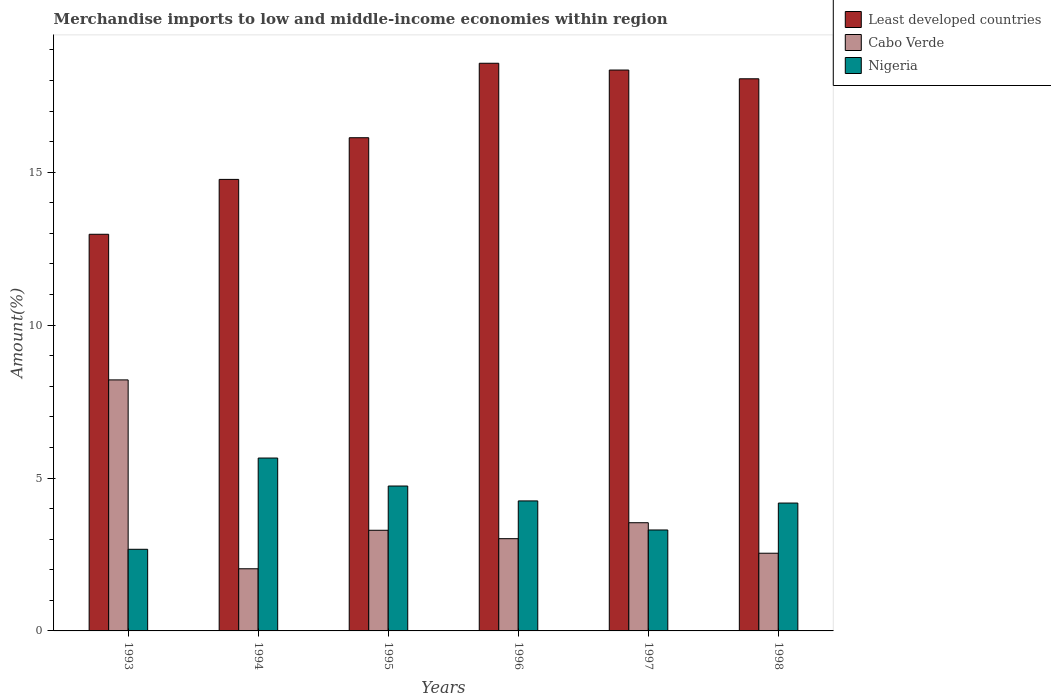How many different coloured bars are there?
Offer a terse response. 3. How many groups of bars are there?
Offer a very short reply. 6. Are the number of bars per tick equal to the number of legend labels?
Keep it short and to the point. Yes. How many bars are there on the 1st tick from the left?
Make the answer very short. 3. How many bars are there on the 6th tick from the right?
Your answer should be compact. 3. What is the label of the 3rd group of bars from the left?
Ensure brevity in your answer.  1995. What is the percentage of amount earned from merchandise imports in Least developed countries in 1997?
Your response must be concise. 18.34. Across all years, what is the maximum percentage of amount earned from merchandise imports in Cabo Verde?
Your response must be concise. 8.21. Across all years, what is the minimum percentage of amount earned from merchandise imports in Least developed countries?
Your response must be concise. 12.97. In which year was the percentage of amount earned from merchandise imports in Nigeria minimum?
Your answer should be very brief. 1993. What is the total percentage of amount earned from merchandise imports in Cabo Verde in the graph?
Give a very brief answer. 22.63. What is the difference between the percentage of amount earned from merchandise imports in Cabo Verde in 1994 and that in 1996?
Provide a short and direct response. -0.98. What is the difference between the percentage of amount earned from merchandise imports in Least developed countries in 1993 and the percentage of amount earned from merchandise imports in Nigeria in 1994?
Provide a short and direct response. 7.32. What is the average percentage of amount earned from merchandise imports in Nigeria per year?
Provide a short and direct response. 4.13. In the year 1998, what is the difference between the percentage of amount earned from merchandise imports in Cabo Verde and percentage of amount earned from merchandise imports in Nigeria?
Provide a short and direct response. -1.64. What is the ratio of the percentage of amount earned from merchandise imports in Cabo Verde in 1996 to that in 1998?
Ensure brevity in your answer.  1.19. Is the percentage of amount earned from merchandise imports in Cabo Verde in 1993 less than that in 1996?
Offer a terse response. No. What is the difference between the highest and the second highest percentage of amount earned from merchandise imports in Least developed countries?
Offer a terse response. 0.22. What is the difference between the highest and the lowest percentage of amount earned from merchandise imports in Nigeria?
Give a very brief answer. 2.98. In how many years, is the percentage of amount earned from merchandise imports in Least developed countries greater than the average percentage of amount earned from merchandise imports in Least developed countries taken over all years?
Give a very brief answer. 3. Is the sum of the percentage of amount earned from merchandise imports in Least developed countries in 1995 and 1997 greater than the maximum percentage of amount earned from merchandise imports in Nigeria across all years?
Provide a short and direct response. Yes. What does the 2nd bar from the left in 1998 represents?
Provide a short and direct response. Cabo Verde. What does the 3rd bar from the right in 1996 represents?
Ensure brevity in your answer.  Least developed countries. Is it the case that in every year, the sum of the percentage of amount earned from merchandise imports in Nigeria and percentage of amount earned from merchandise imports in Least developed countries is greater than the percentage of amount earned from merchandise imports in Cabo Verde?
Offer a very short reply. Yes. How many bars are there?
Your answer should be very brief. 18. What is the difference between two consecutive major ticks on the Y-axis?
Keep it short and to the point. 5. Does the graph contain any zero values?
Your answer should be very brief. No. How are the legend labels stacked?
Offer a very short reply. Vertical. What is the title of the graph?
Offer a very short reply. Merchandise imports to low and middle-income economies within region. What is the label or title of the Y-axis?
Make the answer very short. Amount(%). What is the Amount(%) in Least developed countries in 1993?
Your response must be concise. 12.97. What is the Amount(%) in Cabo Verde in 1993?
Provide a succinct answer. 8.21. What is the Amount(%) in Nigeria in 1993?
Make the answer very short. 2.67. What is the Amount(%) of Least developed countries in 1994?
Provide a succinct answer. 14.76. What is the Amount(%) of Cabo Verde in 1994?
Offer a very short reply. 2.03. What is the Amount(%) in Nigeria in 1994?
Keep it short and to the point. 5.65. What is the Amount(%) of Least developed countries in 1995?
Your response must be concise. 16.13. What is the Amount(%) of Cabo Verde in 1995?
Your answer should be very brief. 3.29. What is the Amount(%) in Nigeria in 1995?
Give a very brief answer. 4.74. What is the Amount(%) of Least developed countries in 1996?
Ensure brevity in your answer.  18.56. What is the Amount(%) of Cabo Verde in 1996?
Ensure brevity in your answer.  3.02. What is the Amount(%) of Nigeria in 1996?
Offer a terse response. 4.25. What is the Amount(%) of Least developed countries in 1997?
Keep it short and to the point. 18.34. What is the Amount(%) of Cabo Verde in 1997?
Your answer should be very brief. 3.54. What is the Amount(%) in Nigeria in 1997?
Offer a terse response. 3.3. What is the Amount(%) in Least developed countries in 1998?
Keep it short and to the point. 18.05. What is the Amount(%) of Cabo Verde in 1998?
Offer a terse response. 2.54. What is the Amount(%) in Nigeria in 1998?
Offer a very short reply. 4.18. Across all years, what is the maximum Amount(%) in Least developed countries?
Provide a short and direct response. 18.56. Across all years, what is the maximum Amount(%) of Cabo Verde?
Offer a very short reply. 8.21. Across all years, what is the maximum Amount(%) in Nigeria?
Keep it short and to the point. 5.65. Across all years, what is the minimum Amount(%) in Least developed countries?
Keep it short and to the point. 12.97. Across all years, what is the minimum Amount(%) in Cabo Verde?
Offer a very short reply. 2.03. Across all years, what is the minimum Amount(%) of Nigeria?
Your response must be concise. 2.67. What is the total Amount(%) in Least developed countries in the graph?
Your answer should be very brief. 98.82. What is the total Amount(%) in Cabo Verde in the graph?
Ensure brevity in your answer.  22.63. What is the total Amount(%) in Nigeria in the graph?
Ensure brevity in your answer.  24.79. What is the difference between the Amount(%) in Least developed countries in 1993 and that in 1994?
Provide a succinct answer. -1.79. What is the difference between the Amount(%) of Cabo Verde in 1993 and that in 1994?
Your response must be concise. 6.18. What is the difference between the Amount(%) in Nigeria in 1993 and that in 1994?
Your response must be concise. -2.98. What is the difference between the Amount(%) in Least developed countries in 1993 and that in 1995?
Provide a succinct answer. -3.16. What is the difference between the Amount(%) of Cabo Verde in 1993 and that in 1995?
Provide a short and direct response. 4.92. What is the difference between the Amount(%) in Nigeria in 1993 and that in 1995?
Ensure brevity in your answer.  -2.07. What is the difference between the Amount(%) in Least developed countries in 1993 and that in 1996?
Provide a succinct answer. -5.59. What is the difference between the Amount(%) in Cabo Verde in 1993 and that in 1996?
Your answer should be compact. 5.19. What is the difference between the Amount(%) of Nigeria in 1993 and that in 1996?
Keep it short and to the point. -1.58. What is the difference between the Amount(%) in Least developed countries in 1993 and that in 1997?
Your answer should be compact. -5.37. What is the difference between the Amount(%) of Cabo Verde in 1993 and that in 1997?
Your response must be concise. 4.67. What is the difference between the Amount(%) of Nigeria in 1993 and that in 1997?
Your answer should be compact. -0.63. What is the difference between the Amount(%) of Least developed countries in 1993 and that in 1998?
Make the answer very short. -5.08. What is the difference between the Amount(%) in Cabo Verde in 1993 and that in 1998?
Offer a very short reply. 5.67. What is the difference between the Amount(%) in Nigeria in 1993 and that in 1998?
Offer a terse response. -1.51. What is the difference between the Amount(%) in Least developed countries in 1994 and that in 1995?
Provide a short and direct response. -1.36. What is the difference between the Amount(%) of Cabo Verde in 1994 and that in 1995?
Offer a terse response. -1.26. What is the difference between the Amount(%) of Nigeria in 1994 and that in 1995?
Provide a succinct answer. 0.92. What is the difference between the Amount(%) of Least developed countries in 1994 and that in 1996?
Ensure brevity in your answer.  -3.8. What is the difference between the Amount(%) of Cabo Verde in 1994 and that in 1996?
Your response must be concise. -0.98. What is the difference between the Amount(%) in Nigeria in 1994 and that in 1996?
Your response must be concise. 1.4. What is the difference between the Amount(%) in Least developed countries in 1994 and that in 1997?
Your answer should be very brief. -3.58. What is the difference between the Amount(%) in Cabo Verde in 1994 and that in 1997?
Your answer should be very brief. -1.51. What is the difference between the Amount(%) in Nigeria in 1994 and that in 1997?
Provide a short and direct response. 2.35. What is the difference between the Amount(%) of Least developed countries in 1994 and that in 1998?
Ensure brevity in your answer.  -3.29. What is the difference between the Amount(%) in Cabo Verde in 1994 and that in 1998?
Give a very brief answer. -0.51. What is the difference between the Amount(%) in Nigeria in 1994 and that in 1998?
Give a very brief answer. 1.47. What is the difference between the Amount(%) of Least developed countries in 1995 and that in 1996?
Your answer should be compact. -2.44. What is the difference between the Amount(%) in Cabo Verde in 1995 and that in 1996?
Keep it short and to the point. 0.27. What is the difference between the Amount(%) of Nigeria in 1995 and that in 1996?
Keep it short and to the point. 0.49. What is the difference between the Amount(%) of Least developed countries in 1995 and that in 1997?
Keep it short and to the point. -2.21. What is the difference between the Amount(%) of Cabo Verde in 1995 and that in 1997?
Your answer should be compact. -0.25. What is the difference between the Amount(%) in Nigeria in 1995 and that in 1997?
Your answer should be compact. 1.44. What is the difference between the Amount(%) of Least developed countries in 1995 and that in 1998?
Your answer should be very brief. -1.93. What is the difference between the Amount(%) of Cabo Verde in 1995 and that in 1998?
Keep it short and to the point. 0.75. What is the difference between the Amount(%) in Nigeria in 1995 and that in 1998?
Your answer should be compact. 0.56. What is the difference between the Amount(%) in Least developed countries in 1996 and that in 1997?
Provide a succinct answer. 0.22. What is the difference between the Amount(%) in Cabo Verde in 1996 and that in 1997?
Your answer should be compact. -0.52. What is the difference between the Amount(%) in Nigeria in 1996 and that in 1997?
Provide a short and direct response. 0.95. What is the difference between the Amount(%) in Least developed countries in 1996 and that in 1998?
Make the answer very short. 0.51. What is the difference between the Amount(%) of Cabo Verde in 1996 and that in 1998?
Provide a short and direct response. 0.48. What is the difference between the Amount(%) of Nigeria in 1996 and that in 1998?
Your response must be concise. 0.07. What is the difference between the Amount(%) in Least developed countries in 1997 and that in 1998?
Make the answer very short. 0.29. What is the difference between the Amount(%) in Cabo Verde in 1997 and that in 1998?
Your answer should be very brief. 1. What is the difference between the Amount(%) of Nigeria in 1997 and that in 1998?
Your response must be concise. -0.88. What is the difference between the Amount(%) of Least developed countries in 1993 and the Amount(%) of Cabo Verde in 1994?
Provide a short and direct response. 10.94. What is the difference between the Amount(%) in Least developed countries in 1993 and the Amount(%) in Nigeria in 1994?
Make the answer very short. 7.32. What is the difference between the Amount(%) in Cabo Verde in 1993 and the Amount(%) in Nigeria in 1994?
Give a very brief answer. 2.55. What is the difference between the Amount(%) in Least developed countries in 1993 and the Amount(%) in Cabo Verde in 1995?
Give a very brief answer. 9.68. What is the difference between the Amount(%) in Least developed countries in 1993 and the Amount(%) in Nigeria in 1995?
Provide a short and direct response. 8.23. What is the difference between the Amount(%) in Cabo Verde in 1993 and the Amount(%) in Nigeria in 1995?
Make the answer very short. 3.47. What is the difference between the Amount(%) of Least developed countries in 1993 and the Amount(%) of Cabo Verde in 1996?
Your answer should be very brief. 9.95. What is the difference between the Amount(%) of Least developed countries in 1993 and the Amount(%) of Nigeria in 1996?
Give a very brief answer. 8.72. What is the difference between the Amount(%) in Cabo Verde in 1993 and the Amount(%) in Nigeria in 1996?
Your answer should be very brief. 3.96. What is the difference between the Amount(%) in Least developed countries in 1993 and the Amount(%) in Cabo Verde in 1997?
Provide a succinct answer. 9.43. What is the difference between the Amount(%) of Least developed countries in 1993 and the Amount(%) of Nigeria in 1997?
Provide a succinct answer. 9.67. What is the difference between the Amount(%) of Cabo Verde in 1993 and the Amount(%) of Nigeria in 1997?
Ensure brevity in your answer.  4.91. What is the difference between the Amount(%) of Least developed countries in 1993 and the Amount(%) of Cabo Verde in 1998?
Offer a terse response. 10.43. What is the difference between the Amount(%) in Least developed countries in 1993 and the Amount(%) in Nigeria in 1998?
Your answer should be compact. 8.79. What is the difference between the Amount(%) in Cabo Verde in 1993 and the Amount(%) in Nigeria in 1998?
Provide a succinct answer. 4.03. What is the difference between the Amount(%) of Least developed countries in 1994 and the Amount(%) of Cabo Verde in 1995?
Offer a terse response. 11.47. What is the difference between the Amount(%) of Least developed countries in 1994 and the Amount(%) of Nigeria in 1995?
Give a very brief answer. 10.03. What is the difference between the Amount(%) of Cabo Verde in 1994 and the Amount(%) of Nigeria in 1995?
Offer a very short reply. -2.71. What is the difference between the Amount(%) of Least developed countries in 1994 and the Amount(%) of Cabo Verde in 1996?
Offer a terse response. 11.75. What is the difference between the Amount(%) of Least developed countries in 1994 and the Amount(%) of Nigeria in 1996?
Provide a short and direct response. 10.51. What is the difference between the Amount(%) of Cabo Verde in 1994 and the Amount(%) of Nigeria in 1996?
Offer a very short reply. -2.22. What is the difference between the Amount(%) of Least developed countries in 1994 and the Amount(%) of Cabo Verde in 1997?
Your answer should be compact. 11.23. What is the difference between the Amount(%) of Least developed countries in 1994 and the Amount(%) of Nigeria in 1997?
Your answer should be very brief. 11.46. What is the difference between the Amount(%) of Cabo Verde in 1994 and the Amount(%) of Nigeria in 1997?
Offer a terse response. -1.27. What is the difference between the Amount(%) of Least developed countries in 1994 and the Amount(%) of Cabo Verde in 1998?
Offer a terse response. 12.22. What is the difference between the Amount(%) in Least developed countries in 1994 and the Amount(%) in Nigeria in 1998?
Make the answer very short. 10.58. What is the difference between the Amount(%) in Cabo Verde in 1994 and the Amount(%) in Nigeria in 1998?
Your response must be concise. -2.15. What is the difference between the Amount(%) in Least developed countries in 1995 and the Amount(%) in Cabo Verde in 1996?
Offer a terse response. 13.11. What is the difference between the Amount(%) in Least developed countries in 1995 and the Amount(%) in Nigeria in 1996?
Ensure brevity in your answer.  11.88. What is the difference between the Amount(%) in Cabo Verde in 1995 and the Amount(%) in Nigeria in 1996?
Your answer should be compact. -0.96. What is the difference between the Amount(%) of Least developed countries in 1995 and the Amount(%) of Cabo Verde in 1997?
Your answer should be very brief. 12.59. What is the difference between the Amount(%) of Least developed countries in 1995 and the Amount(%) of Nigeria in 1997?
Offer a terse response. 12.83. What is the difference between the Amount(%) in Cabo Verde in 1995 and the Amount(%) in Nigeria in 1997?
Offer a terse response. -0.01. What is the difference between the Amount(%) of Least developed countries in 1995 and the Amount(%) of Cabo Verde in 1998?
Offer a terse response. 13.59. What is the difference between the Amount(%) in Least developed countries in 1995 and the Amount(%) in Nigeria in 1998?
Give a very brief answer. 11.95. What is the difference between the Amount(%) in Cabo Verde in 1995 and the Amount(%) in Nigeria in 1998?
Give a very brief answer. -0.89. What is the difference between the Amount(%) of Least developed countries in 1996 and the Amount(%) of Cabo Verde in 1997?
Your response must be concise. 15.02. What is the difference between the Amount(%) in Least developed countries in 1996 and the Amount(%) in Nigeria in 1997?
Ensure brevity in your answer.  15.26. What is the difference between the Amount(%) in Cabo Verde in 1996 and the Amount(%) in Nigeria in 1997?
Provide a short and direct response. -0.28. What is the difference between the Amount(%) of Least developed countries in 1996 and the Amount(%) of Cabo Verde in 1998?
Keep it short and to the point. 16.02. What is the difference between the Amount(%) in Least developed countries in 1996 and the Amount(%) in Nigeria in 1998?
Make the answer very short. 14.38. What is the difference between the Amount(%) of Cabo Verde in 1996 and the Amount(%) of Nigeria in 1998?
Make the answer very short. -1.16. What is the difference between the Amount(%) in Least developed countries in 1997 and the Amount(%) in Cabo Verde in 1998?
Provide a succinct answer. 15.8. What is the difference between the Amount(%) of Least developed countries in 1997 and the Amount(%) of Nigeria in 1998?
Provide a short and direct response. 14.16. What is the difference between the Amount(%) of Cabo Verde in 1997 and the Amount(%) of Nigeria in 1998?
Offer a very short reply. -0.64. What is the average Amount(%) of Least developed countries per year?
Give a very brief answer. 16.47. What is the average Amount(%) in Cabo Verde per year?
Offer a terse response. 3.77. What is the average Amount(%) in Nigeria per year?
Make the answer very short. 4.13. In the year 1993, what is the difference between the Amount(%) in Least developed countries and Amount(%) in Cabo Verde?
Offer a very short reply. 4.76. In the year 1993, what is the difference between the Amount(%) of Least developed countries and Amount(%) of Nigeria?
Give a very brief answer. 10.3. In the year 1993, what is the difference between the Amount(%) of Cabo Verde and Amount(%) of Nigeria?
Your answer should be compact. 5.54. In the year 1994, what is the difference between the Amount(%) of Least developed countries and Amount(%) of Cabo Verde?
Give a very brief answer. 12.73. In the year 1994, what is the difference between the Amount(%) in Least developed countries and Amount(%) in Nigeria?
Your answer should be very brief. 9.11. In the year 1994, what is the difference between the Amount(%) in Cabo Verde and Amount(%) in Nigeria?
Your answer should be compact. -3.62. In the year 1995, what is the difference between the Amount(%) in Least developed countries and Amount(%) in Cabo Verde?
Make the answer very short. 12.84. In the year 1995, what is the difference between the Amount(%) in Least developed countries and Amount(%) in Nigeria?
Ensure brevity in your answer.  11.39. In the year 1995, what is the difference between the Amount(%) of Cabo Verde and Amount(%) of Nigeria?
Give a very brief answer. -1.45. In the year 1996, what is the difference between the Amount(%) in Least developed countries and Amount(%) in Cabo Verde?
Make the answer very short. 15.55. In the year 1996, what is the difference between the Amount(%) of Least developed countries and Amount(%) of Nigeria?
Your response must be concise. 14.31. In the year 1996, what is the difference between the Amount(%) in Cabo Verde and Amount(%) in Nigeria?
Provide a succinct answer. -1.23. In the year 1997, what is the difference between the Amount(%) in Least developed countries and Amount(%) in Cabo Verde?
Keep it short and to the point. 14.8. In the year 1997, what is the difference between the Amount(%) of Least developed countries and Amount(%) of Nigeria?
Your answer should be very brief. 15.04. In the year 1997, what is the difference between the Amount(%) of Cabo Verde and Amount(%) of Nigeria?
Make the answer very short. 0.24. In the year 1998, what is the difference between the Amount(%) of Least developed countries and Amount(%) of Cabo Verde?
Provide a succinct answer. 15.51. In the year 1998, what is the difference between the Amount(%) of Least developed countries and Amount(%) of Nigeria?
Give a very brief answer. 13.87. In the year 1998, what is the difference between the Amount(%) in Cabo Verde and Amount(%) in Nigeria?
Make the answer very short. -1.64. What is the ratio of the Amount(%) in Least developed countries in 1993 to that in 1994?
Provide a short and direct response. 0.88. What is the ratio of the Amount(%) in Cabo Verde in 1993 to that in 1994?
Give a very brief answer. 4.04. What is the ratio of the Amount(%) in Nigeria in 1993 to that in 1994?
Your response must be concise. 0.47. What is the ratio of the Amount(%) of Least developed countries in 1993 to that in 1995?
Provide a short and direct response. 0.8. What is the ratio of the Amount(%) in Cabo Verde in 1993 to that in 1995?
Provide a short and direct response. 2.49. What is the ratio of the Amount(%) in Nigeria in 1993 to that in 1995?
Your response must be concise. 0.56. What is the ratio of the Amount(%) in Least developed countries in 1993 to that in 1996?
Your response must be concise. 0.7. What is the ratio of the Amount(%) in Cabo Verde in 1993 to that in 1996?
Ensure brevity in your answer.  2.72. What is the ratio of the Amount(%) in Nigeria in 1993 to that in 1996?
Provide a succinct answer. 0.63. What is the ratio of the Amount(%) of Least developed countries in 1993 to that in 1997?
Provide a succinct answer. 0.71. What is the ratio of the Amount(%) of Cabo Verde in 1993 to that in 1997?
Provide a succinct answer. 2.32. What is the ratio of the Amount(%) in Nigeria in 1993 to that in 1997?
Ensure brevity in your answer.  0.81. What is the ratio of the Amount(%) in Least developed countries in 1993 to that in 1998?
Offer a terse response. 0.72. What is the ratio of the Amount(%) in Cabo Verde in 1993 to that in 1998?
Give a very brief answer. 3.23. What is the ratio of the Amount(%) in Nigeria in 1993 to that in 1998?
Ensure brevity in your answer.  0.64. What is the ratio of the Amount(%) in Least developed countries in 1994 to that in 1995?
Make the answer very short. 0.92. What is the ratio of the Amount(%) of Cabo Verde in 1994 to that in 1995?
Your answer should be very brief. 0.62. What is the ratio of the Amount(%) of Nigeria in 1994 to that in 1995?
Your answer should be very brief. 1.19. What is the ratio of the Amount(%) in Least developed countries in 1994 to that in 1996?
Ensure brevity in your answer.  0.8. What is the ratio of the Amount(%) of Cabo Verde in 1994 to that in 1996?
Your answer should be compact. 0.67. What is the ratio of the Amount(%) of Nigeria in 1994 to that in 1996?
Your response must be concise. 1.33. What is the ratio of the Amount(%) of Least developed countries in 1994 to that in 1997?
Provide a short and direct response. 0.81. What is the ratio of the Amount(%) in Cabo Verde in 1994 to that in 1997?
Provide a succinct answer. 0.57. What is the ratio of the Amount(%) in Nigeria in 1994 to that in 1997?
Provide a succinct answer. 1.71. What is the ratio of the Amount(%) of Least developed countries in 1994 to that in 1998?
Offer a very short reply. 0.82. What is the ratio of the Amount(%) of Cabo Verde in 1994 to that in 1998?
Make the answer very short. 0.8. What is the ratio of the Amount(%) of Nigeria in 1994 to that in 1998?
Your answer should be very brief. 1.35. What is the ratio of the Amount(%) in Least developed countries in 1995 to that in 1996?
Your answer should be very brief. 0.87. What is the ratio of the Amount(%) of Cabo Verde in 1995 to that in 1996?
Your answer should be very brief. 1.09. What is the ratio of the Amount(%) in Nigeria in 1995 to that in 1996?
Offer a terse response. 1.11. What is the ratio of the Amount(%) of Least developed countries in 1995 to that in 1997?
Your answer should be compact. 0.88. What is the ratio of the Amount(%) in Cabo Verde in 1995 to that in 1997?
Offer a very short reply. 0.93. What is the ratio of the Amount(%) in Nigeria in 1995 to that in 1997?
Provide a short and direct response. 1.44. What is the ratio of the Amount(%) in Least developed countries in 1995 to that in 1998?
Provide a short and direct response. 0.89. What is the ratio of the Amount(%) of Cabo Verde in 1995 to that in 1998?
Provide a succinct answer. 1.3. What is the ratio of the Amount(%) of Nigeria in 1995 to that in 1998?
Ensure brevity in your answer.  1.13. What is the ratio of the Amount(%) in Least developed countries in 1996 to that in 1997?
Your answer should be compact. 1.01. What is the ratio of the Amount(%) in Cabo Verde in 1996 to that in 1997?
Your response must be concise. 0.85. What is the ratio of the Amount(%) in Nigeria in 1996 to that in 1997?
Offer a terse response. 1.29. What is the ratio of the Amount(%) of Least developed countries in 1996 to that in 1998?
Give a very brief answer. 1.03. What is the ratio of the Amount(%) of Cabo Verde in 1996 to that in 1998?
Provide a short and direct response. 1.19. What is the ratio of the Amount(%) of Nigeria in 1996 to that in 1998?
Give a very brief answer. 1.02. What is the ratio of the Amount(%) in Least developed countries in 1997 to that in 1998?
Give a very brief answer. 1.02. What is the ratio of the Amount(%) of Cabo Verde in 1997 to that in 1998?
Make the answer very short. 1.39. What is the ratio of the Amount(%) in Nigeria in 1997 to that in 1998?
Offer a very short reply. 0.79. What is the difference between the highest and the second highest Amount(%) of Least developed countries?
Offer a very short reply. 0.22. What is the difference between the highest and the second highest Amount(%) of Cabo Verde?
Make the answer very short. 4.67. What is the difference between the highest and the second highest Amount(%) in Nigeria?
Give a very brief answer. 0.92. What is the difference between the highest and the lowest Amount(%) in Least developed countries?
Offer a terse response. 5.59. What is the difference between the highest and the lowest Amount(%) in Cabo Verde?
Make the answer very short. 6.18. What is the difference between the highest and the lowest Amount(%) in Nigeria?
Offer a very short reply. 2.98. 